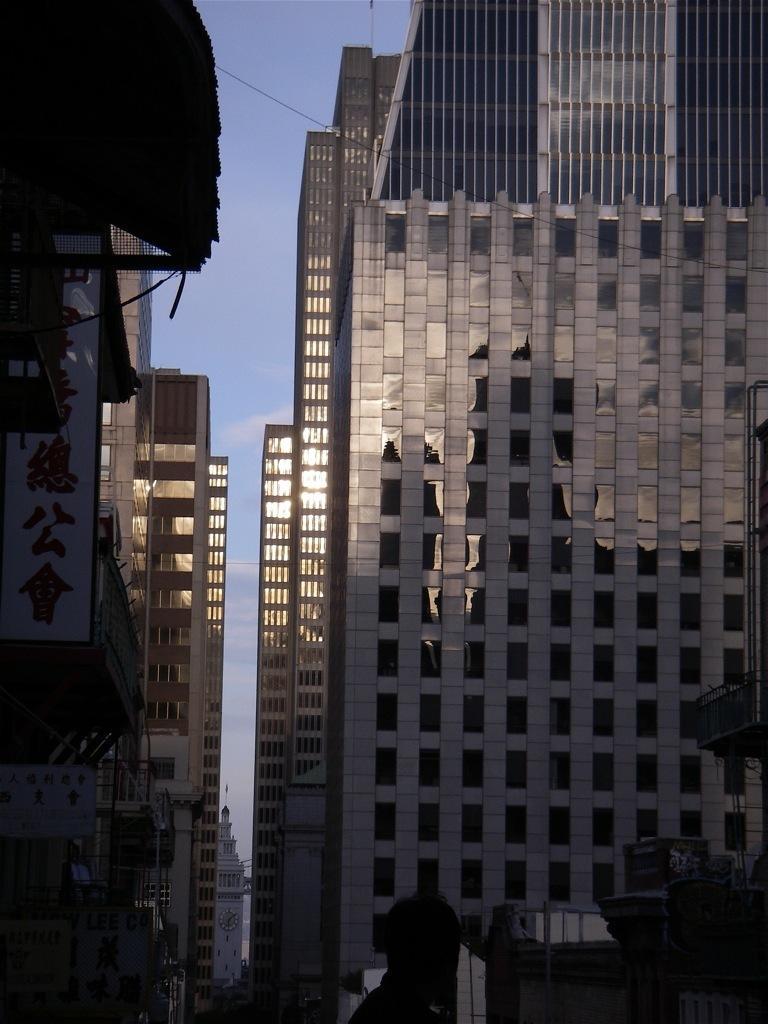Please provide a concise description of this image. There is a person. In the background, there are glass buildings and there are clouds in the blue sky. 